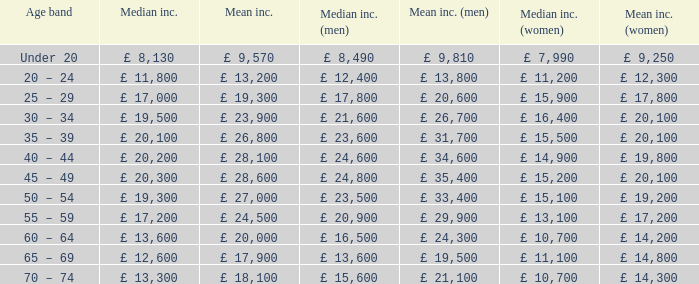Name the median income for age band being under 20 £ 8,130. 